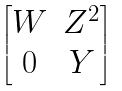Convert formula to latex. <formula><loc_0><loc_0><loc_500><loc_500>\begin{bmatrix} W & Z ^ { 2 } \\ 0 & Y \end{bmatrix}</formula> 